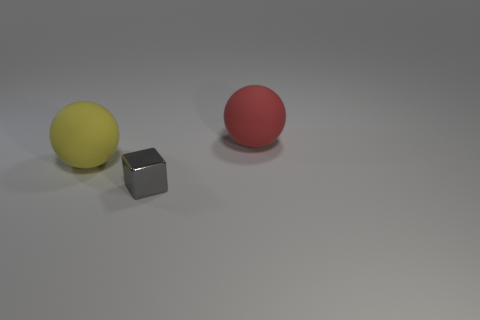Add 3 red rubber spheres. How many objects exist? 6 Subtract all balls. How many objects are left? 1 Subtract all purple rubber cylinders. Subtract all gray metal things. How many objects are left? 2 Add 3 large yellow matte things. How many large yellow matte things are left? 4 Add 2 brown spheres. How many brown spheres exist? 2 Subtract 0 green cylinders. How many objects are left? 3 